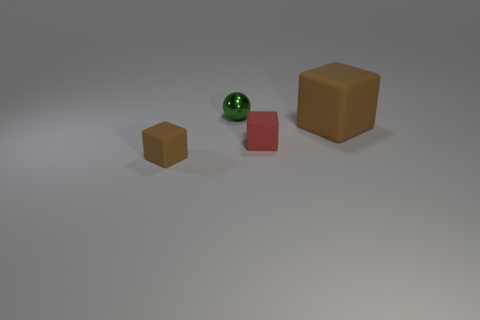Add 3 metal objects. How many objects exist? 7 Subtract all metallic spheres. Subtract all green matte cubes. How many objects are left? 3 Add 3 large brown rubber cubes. How many large brown rubber cubes are left? 4 Add 4 brown cubes. How many brown cubes exist? 6 Subtract 0 blue blocks. How many objects are left? 4 Subtract all spheres. How many objects are left? 3 